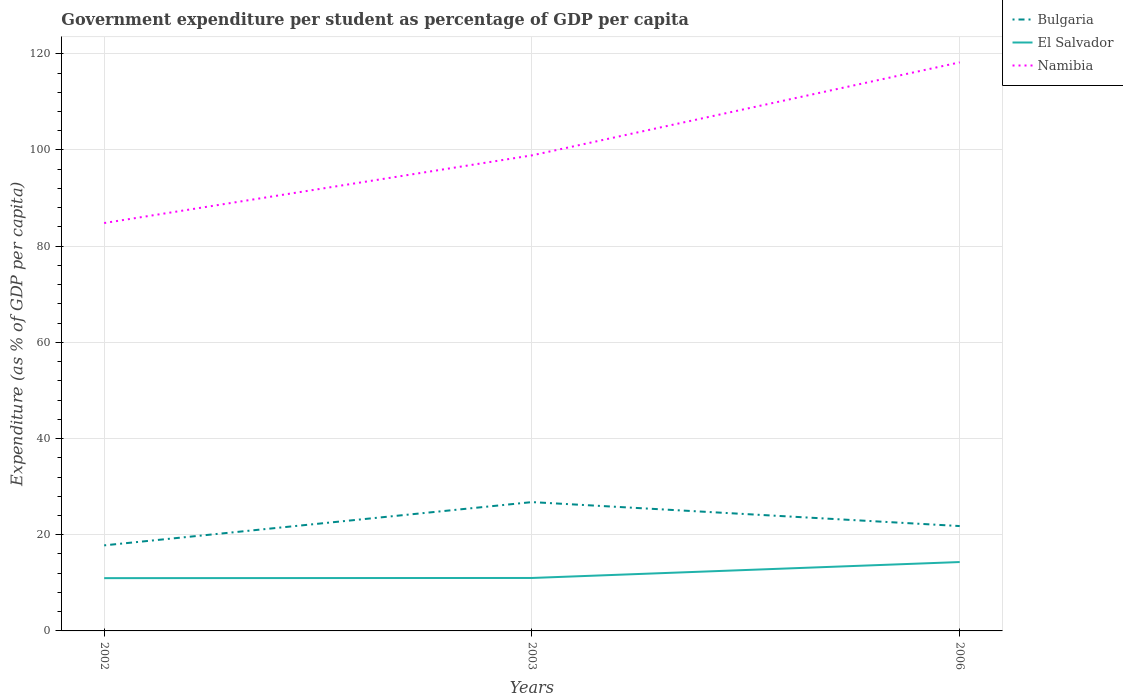Is the number of lines equal to the number of legend labels?
Provide a short and direct response. Yes. Across all years, what is the maximum percentage of expenditure per student in Namibia?
Give a very brief answer. 84.81. In which year was the percentage of expenditure per student in Bulgaria maximum?
Keep it short and to the point. 2002. What is the total percentage of expenditure per student in El Salvador in the graph?
Ensure brevity in your answer.  -3.31. What is the difference between the highest and the second highest percentage of expenditure per student in El Salvador?
Your response must be concise. 3.35. How many lines are there?
Ensure brevity in your answer.  3. Does the graph contain any zero values?
Your response must be concise. No. Does the graph contain grids?
Give a very brief answer. Yes. Where does the legend appear in the graph?
Offer a very short reply. Top right. How are the legend labels stacked?
Keep it short and to the point. Vertical. What is the title of the graph?
Offer a terse response. Government expenditure per student as percentage of GDP per capita. What is the label or title of the X-axis?
Provide a succinct answer. Years. What is the label or title of the Y-axis?
Give a very brief answer. Expenditure (as % of GDP per capita). What is the Expenditure (as % of GDP per capita) of Bulgaria in 2002?
Keep it short and to the point. 17.79. What is the Expenditure (as % of GDP per capita) of El Salvador in 2002?
Your response must be concise. 10.97. What is the Expenditure (as % of GDP per capita) of Namibia in 2002?
Offer a terse response. 84.81. What is the Expenditure (as % of GDP per capita) in Bulgaria in 2003?
Give a very brief answer. 26.78. What is the Expenditure (as % of GDP per capita) in El Salvador in 2003?
Keep it short and to the point. 11.01. What is the Expenditure (as % of GDP per capita) of Namibia in 2003?
Provide a short and direct response. 98.88. What is the Expenditure (as % of GDP per capita) in Bulgaria in 2006?
Your answer should be compact. 21.8. What is the Expenditure (as % of GDP per capita) in El Salvador in 2006?
Make the answer very short. 14.32. What is the Expenditure (as % of GDP per capita) in Namibia in 2006?
Keep it short and to the point. 118.22. Across all years, what is the maximum Expenditure (as % of GDP per capita) of Bulgaria?
Your answer should be very brief. 26.78. Across all years, what is the maximum Expenditure (as % of GDP per capita) of El Salvador?
Your response must be concise. 14.32. Across all years, what is the maximum Expenditure (as % of GDP per capita) in Namibia?
Give a very brief answer. 118.22. Across all years, what is the minimum Expenditure (as % of GDP per capita) in Bulgaria?
Your answer should be compact. 17.79. Across all years, what is the minimum Expenditure (as % of GDP per capita) of El Salvador?
Make the answer very short. 10.97. Across all years, what is the minimum Expenditure (as % of GDP per capita) in Namibia?
Your answer should be very brief. 84.81. What is the total Expenditure (as % of GDP per capita) in Bulgaria in the graph?
Your response must be concise. 66.38. What is the total Expenditure (as % of GDP per capita) in El Salvador in the graph?
Make the answer very short. 36.3. What is the total Expenditure (as % of GDP per capita) in Namibia in the graph?
Keep it short and to the point. 301.9. What is the difference between the Expenditure (as % of GDP per capita) in Bulgaria in 2002 and that in 2003?
Provide a succinct answer. -8.99. What is the difference between the Expenditure (as % of GDP per capita) of El Salvador in 2002 and that in 2003?
Your answer should be very brief. -0.04. What is the difference between the Expenditure (as % of GDP per capita) in Namibia in 2002 and that in 2003?
Make the answer very short. -14.07. What is the difference between the Expenditure (as % of GDP per capita) in Bulgaria in 2002 and that in 2006?
Offer a terse response. -4.01. What is the difference between the Expenditure (as % of GDP per capita) in El Salvador in 2002 and that in 2006?
Ensure brevity in your answer.  -3.35. What is the difference between the Expenditure (as % of GDP per capita) in Namibia in 2002 and that in 2006?
Offer a terse response. -33.41. What is the difference between the Expenditure (as % of GDP per capita) in Bulgaria in 2003 and that in 2006?
Offer a very short reply. 4.98. What is the difference between the Expenditure (as % of GDP per capita) of El Salvador in 2003 and that in 2006?
Ensure brevity in your answer.  -3.31. What is the difference between the Expenditure (as % of GDP per capita) of Namibia in 2003 and that in 2006?
Provide a short and direct response. -19.34. What is the difference between the Expenditure (as % of GDP per capita) in Bulgaria in 2002 and the Expenditure (as % of GDP per capita) in El Salvador in 2003?
Offer a very short reply. 6.78. What is the difference between the Expenditure (as % of GDP per capita) in Bulgaria in 2002 and the Expenditure (as % of GDP per capita) in Namibia in 2003?
Offer a very short reply. -81.09. What is the difference between the Expenditure (as % of GDP per capita) of El Salvador in 2002 and the Expenditure (as % of GDP per capita) of Namibia in 2003?
Offer a terse response. -87.91. What is the difference between the Expenditure (as % of GDP per capita) in Bulgaria in 2002 and the Expenditure (as % of GDP per capita) in El Salvador in 2006?
Provide a succinct answer. 3.47. What is the difference between the Expenditure (as % of GDP per capita) of Bulgaria in 2002 and the Expenditure (as % of GDP per capita) of Namibia in 2006?
Offer a terse response. -100.43. What is the difference between the Expenditure (as % of GDP per capita) in El Salvador in 2002 and the Expenditure (as % of GDP per capita) in Namibia in 2006?
Provide a succinct answer. -107.24. What is the difference between the Expenditure (as % of GDP per capita) in Bulgaria in 2003 and the Expenditure (as % of GDP per capita) in El Salvador in 2006?
Your response must be concise. 12.46. What is the difference between the Expenditure (as % of GDP per capita) of Bulgaria in 2003 and the Expenditure (as % of GDP per capita) of Namibia in 2006?
Your response must be concise. -91.43. What is the difference between the Expenditure (as % of GDP per capita) in El Salvador in 2003 and the Expenditure (as % of GDP per capita) in Namibia in 2006?
Provide a succinct answer. -107.21. What is the average Expenditure (as % of GDP per capita) in Bulgaria per year?
Your response must be concise. 22.13. What is the average Expenditure (as % of GDP per capita) in El Salvador per year?
Keep it short and to the point. 12.1. What is the average Expenditure (as % of GDP per capita) in Namibia per year?
Keep it short and to the point. 100.63. In the year 2002, what is the difference between the Expenditure (as % of GDP per capita) in Bulgaria and Expenditure (as % of GDP per capita) in El Salvador?
Your answer should be compact. 6.82. In the year 2002, what is the difference between the Expenditure (as % of GDP per capita) of Bulgaria and Expenditure (as % of GDP per capita) of Namibia?
Give a very brief answer. -67.02. In the year 2002, what is the difference between the Expenditure (as % of GDP per capita) in El Salvador and Expenditure (as % of GDP per capita) in Namibia?
Offer a very short reply. -73.84. In the year 2003, what is the difference between the Expenditure (as % of GDP per capita) of Bulgaria and Expenditure (as % of GDP per capita) of El Salvador?
Offer a terse response. 15.78. In the year 2003, what is the difference between the Expenditure (as % of GDP per capita) of Bulgaria and Expenditure (as % of GDP per capita) of Namibia?
Your response must be concise. -72.09. In the year 2003, what is the difference between the Expenditure (as % of GDP per capita) in El Salvador and Expenditure (as % of GDP per capita) in Namibia?
Ensure brevity in your answer.  -87.87. In the year 2006, what is the difference between the Expenditure (as % of GDP per capita) of Bulgaria and Expenditure (as % of GDP per capita) of El Salvador?
Offer a very short reply. 7.48. In the year 2006, what is the difference between the Expenditure (as % of GDP per capita) in Bulgaria and Expenditure (as % of GDP per capita) in Namibia?
Ensure brevity in your answer.  -96.41. In the year 2006, what is the difference between the Expenditure (as % of GDP per capita) in El Salvador and Expenditure (as % of GDP per capita) in Namibia?
Your answer should be compact. -103.89. What is the ratio of the Expenditure (as % of GDP per capita) of Bulgaria in 2002 to that in 2003?
Provide a succinct answer. 0.66. What is the ratio of the Expenditure (as % of GDP per capita) of El Salvador in 2002 to that in 2003?
Offer a very short reply. 1. What is the ratio of the Expenditure (as % of GDP per capita) in Namibia in 2002 to that in 2003?
Offer a very short reply. 0.86. What is the ratio of the Expenditure (as % of GDP per capita) of Bulgaria in 2002 to that in 2006?
Offer a terse response. 0.82. What is the ratio of the Expenditure (as % of GDP per capita) of El Salvador in 2002 to that in 2006?
Keep it short and to the point. 0.77. What is the ratio of the Expenditure (as % of GDP per capita) of Namibia in 2002 to that in 2006?
Provide a short and direct response. 0.72. What is the ratio of the Expenditure (as % of GDP per capita) of Bulgaria in 2003 to that in 2006?
Offer a terse response. 1.23. What is the ratio of the Expenditure (as % of GDP per capita) of El Salvador in 2003 to that in 2006?
Ensure brevity in your answer.  0.77. What is the ratio of the Expenditure (as % of GDP per capita) in Namibia in 2003 to that in 2006?
Provide a short and direct response. 0.84. What is the difference between the highest and the second highest Expenditure (as % of GDP per capita) in Bulgaria?
Give a very brief answer. 4.98. What is the difference between the highest and the second highest Expenditure (as % of GDP per capita) in El Salvador?
Make the answer very short. 3.31. What is the difference between the highest and the second highest Expenditure (as % of GDP per capita) of Namibia?
Your answer should be compact. 19.34. What is the difference between the highest and the lowest Expenditure (as % of GDP per capita) in Bulgaria?
Your answer should be compact. 8.99. What is the difference between the highest and the lowest Expenditure (as % of GDP per capita) of El Salvador?
Your response must be concise. 3.35. What is the difference between the highest and the lowest Expenditure (as % of GDP per capita) in Namibia?
Provide a short and direct response. 33.41. 